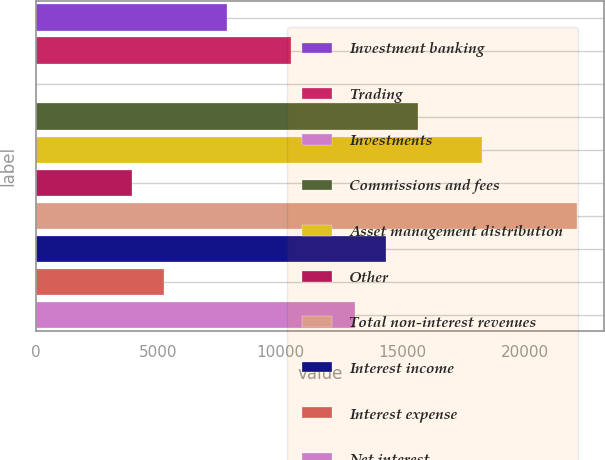Convert chart. <chart><loc_0><loc_0><loc_500><loc_500><bar_chart><fcel>Investment banking<fcel>Trading<fcel>Investments<fcel>Commissions and fees<fcel>Asset management distribution<fcel>Other<fcel>Total non-interest revenues<fcel>Interest income<fcel>Interest expense<fcel>Net interest<nl><fcel>7824.4<fcel>10429.2<fcel>10<fcel>15638.8<fcel>18243.6<fcel>3917.2<fcel>22150.8<fcel>14336.4<fcel>5219.6<fcel>13034<nl></chart> 